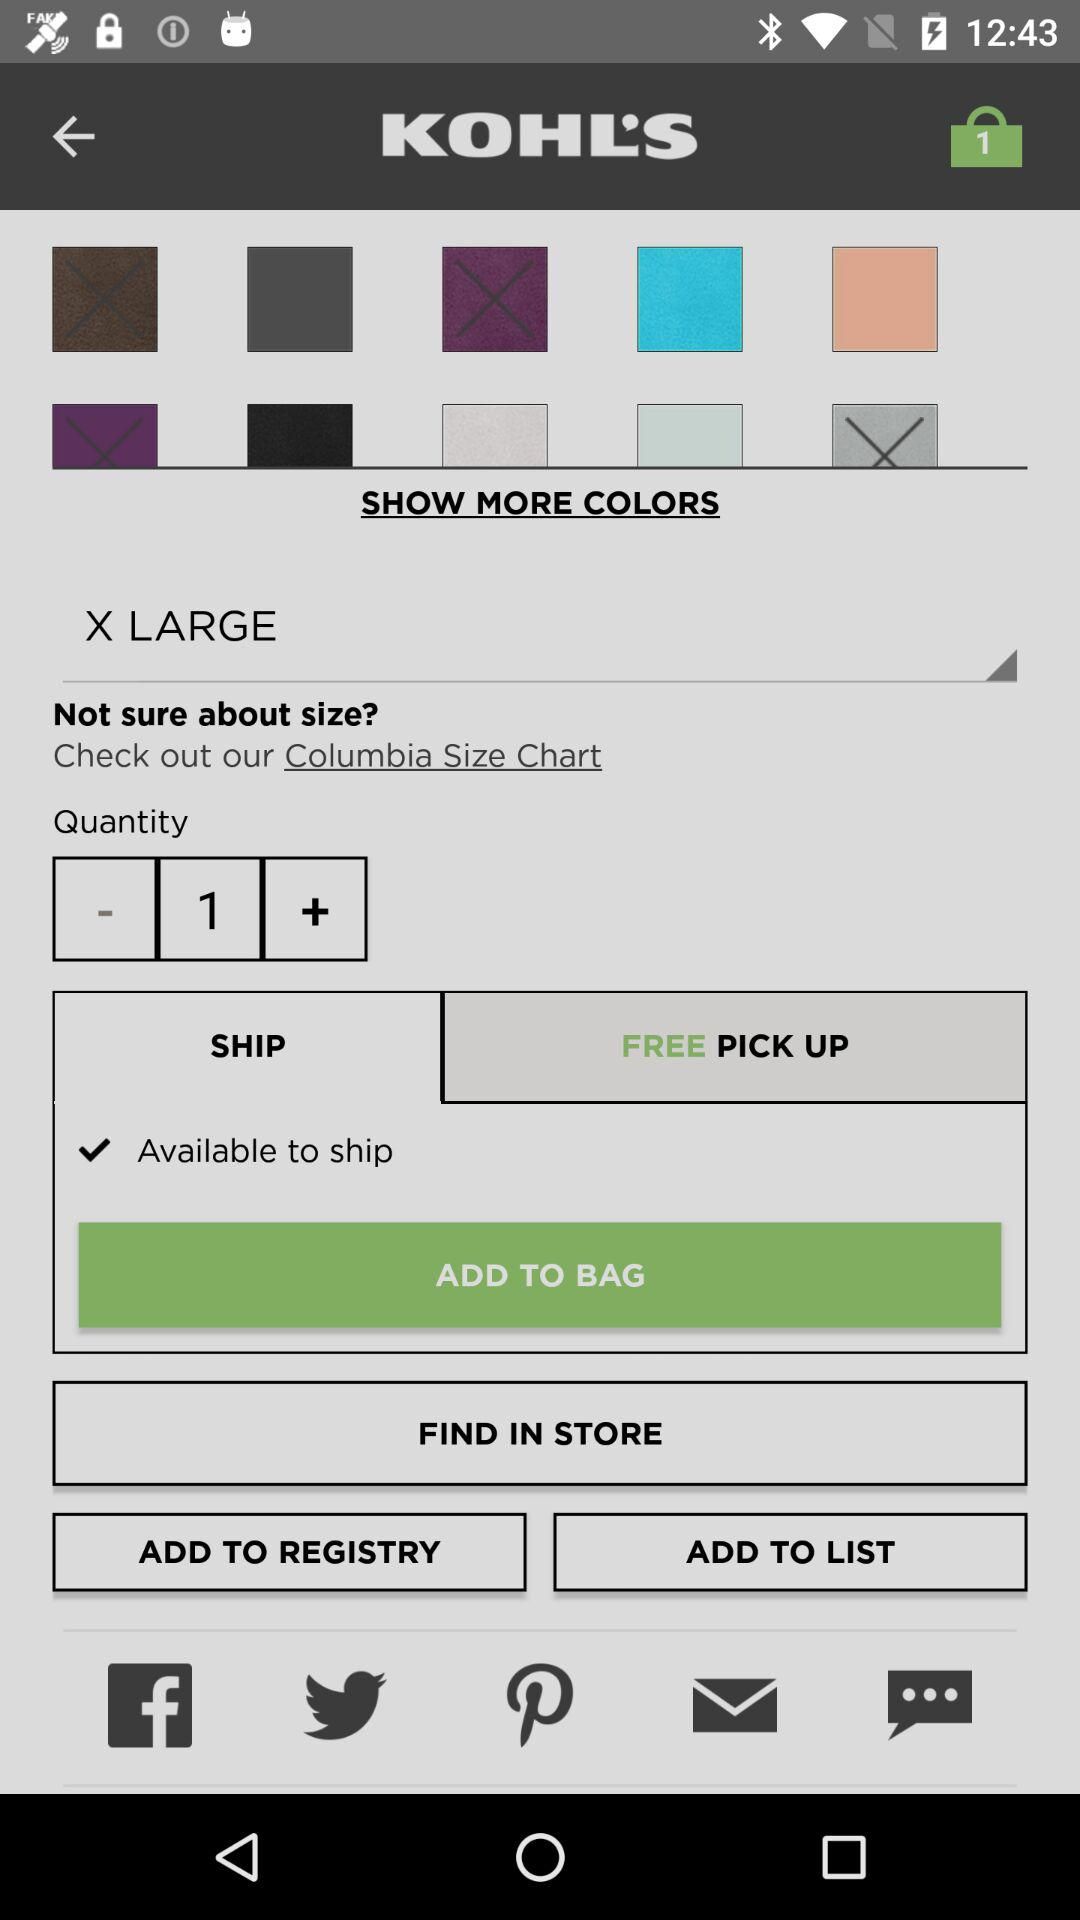What is the size? The size is X-Large. 